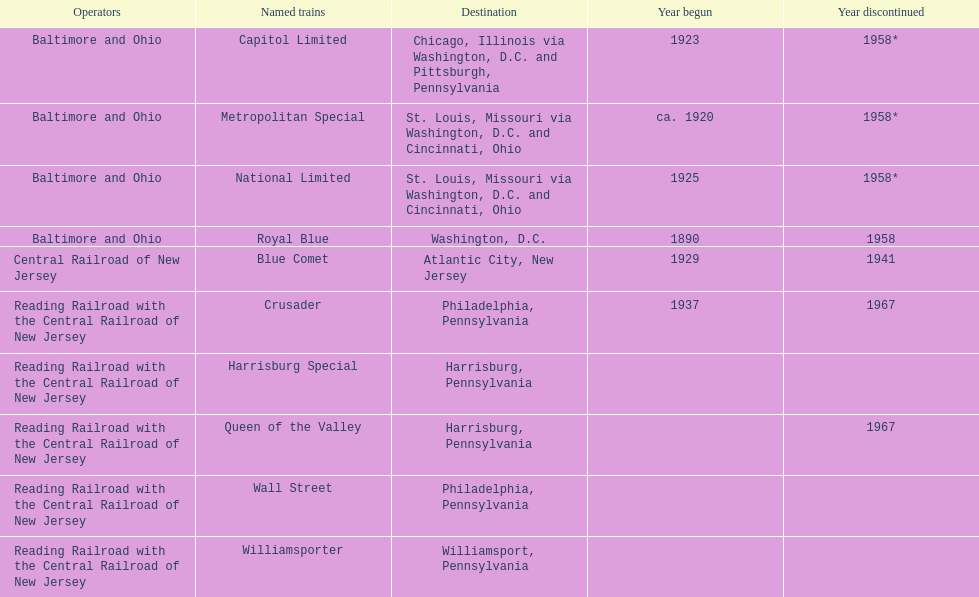Which was the first train to commence service? Royal Blue. 